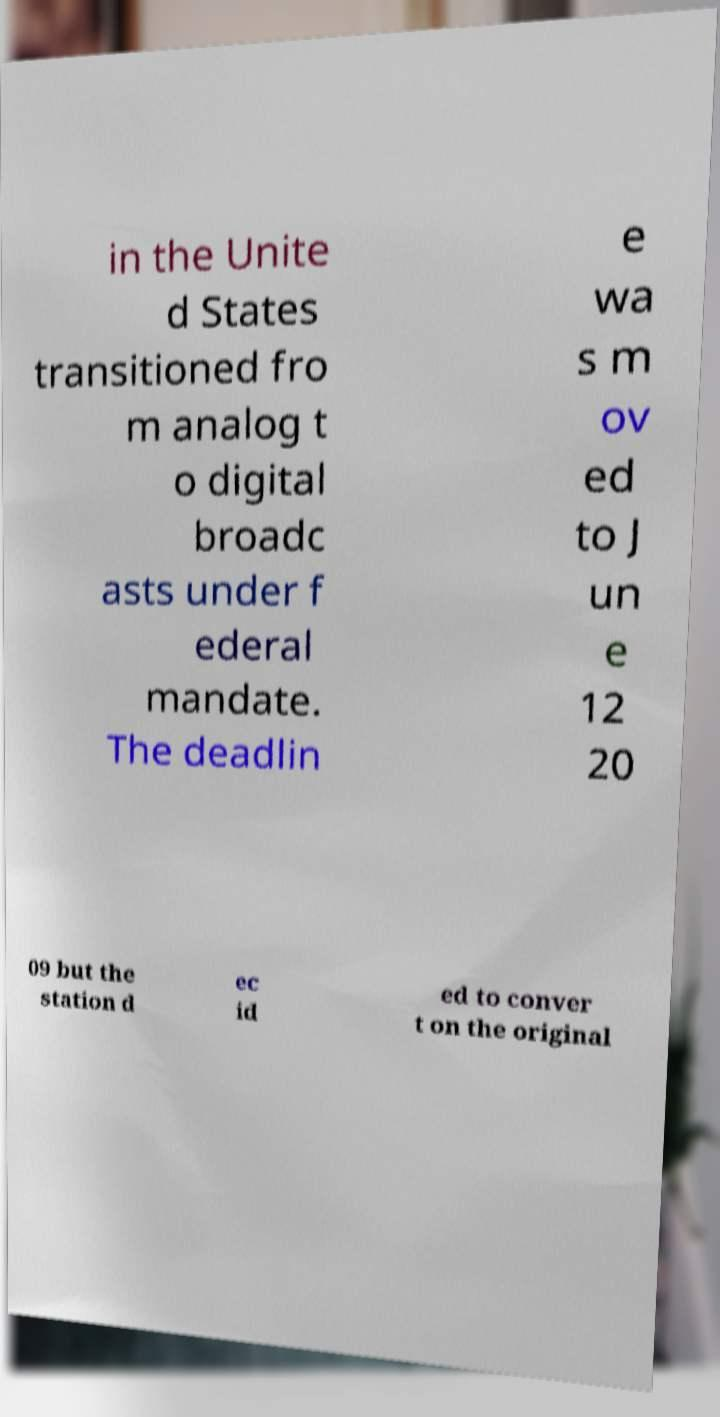Could you assist in decoding the text presented in this image and type it out clearly? in the Unite d States transitioned fro m analog t o digital broadc asts under f ederal mandate. The deadlin e wa s m ov ed to J un e 12 20 09 but the station d ec id ed to conver t on the original 